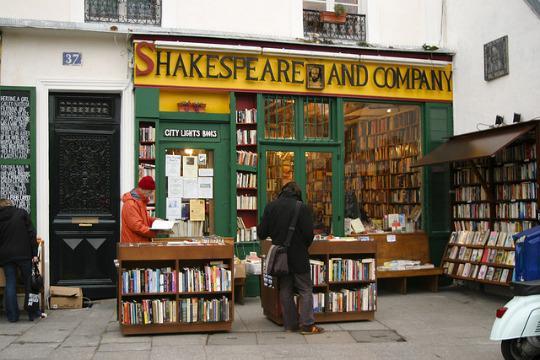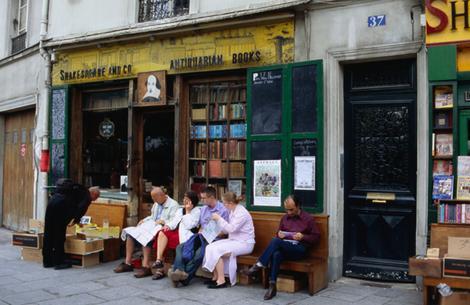The first image is the image on the left, the second image is the image on the right. Examine the images to the left and right. Is the description "People are seated outside in a shopping area." accurate? Answer yes or no. Yes. The first image is the image on the left, the second image is the image on the right. Analyze the images presented: Is the assertion "There are people seated." valid? Answer yes or no. Yes. 